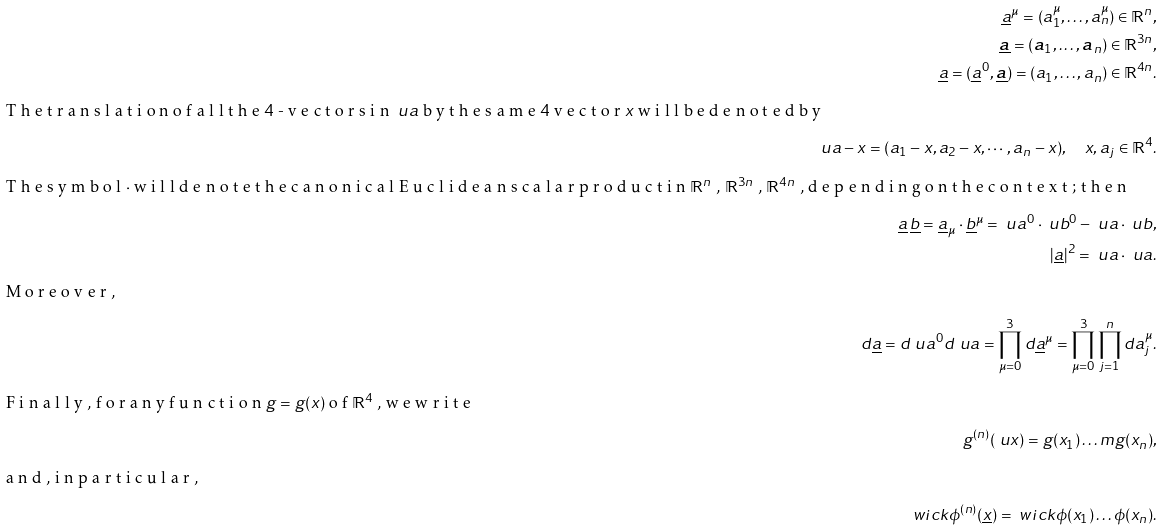Convert formula to latex. <formula><loc_0><loc_0><loc_500><loc_500>\underline { a } ^ { \mu } = ( a _ { 1 } ^ { \mu } , \dots , a _ { n } ^ { \mu } ) \in \mathbb { R } ^ { n } , \\ \underline { \boldsymbol a } = ( { \boldsymbol a } _ { 1 } , \dots , { \boldsymbol a } _ { n } ) \in \mathbb { R } ^ { 3 n } , \\ \underline { a } = ( \underline { a } ^ { 0 } , \underline { \boldsymbol a } ) = ( a _ { 1 } , \dots , a _ { n } ) \in \mathbb { R } ^ { 4 n } . \\ \intertext { T h e t r a n s l a t i o n o f a l l t h e $ 4 $ - v e c t o r s i n $ \ u a $ b y t h e s a m e $ 4 $ v e c t o r $ x $ w i l l b e d e n o t e d b y } \ u a - x = ( a _ { 1 } - x , a _ { 2 } - x , \cdots , a _ { n } - x ) , \quad x , a _ { j } \in \mathbb { R } ^ { 4 } . \\ \intertext { T h e s y m b o l $ \cdot $ w i l l d e n o t e t h e c a n o n i c a l E u c l i d e a n s c a l a r p r o d u c t i n $ \mathbb { R } ^ { n } $ , $ \mathbb { R } ^ { 3 n } $ , $ \mathbb { R } ^ { 4 n } $ , d e p e n d i n g o n t h e c o n t e x t ; t h e n } \underline { a } \, \underline { b } = \underline { a } _ { \mu } \cdot \underline { b } ^ { \mu } = \ u a ^ { 0 } \cdot \ u b ^ { 0 } - \boldsymbol \ u a \cdot \boldsymbol \ u b , \\ | \underline { a } | ^ { 2 } = \ u a \cdot \ u a . \intertext { M o r e o v e r , } d \underline { a } = d \ u a ^ { 0 } d \boldsymbol \ u a = \prod _ { \mu = 0 } ^ { 3 } d \underline { a } ^ { \mu } = \prod _ { \mu = 0 } ^ { 3 } \prod _ { j = 1 } ^ { n } d a ^ { \mu } _ { j } . \\ \intertext { F i n a l l y , f o r a n y f u n c t i o n $ g = g ( x ) $ o f $ \mathbb { R } ^ { 4 } $ , w e w r i t e } g ^ { ( n ) } ( \ u x ) = g ( x _ { 1 } ) \dots m g ( x _ { n } ) , \\ \intertext { a n d , i n p a r t i c u l a r , } \ w i c k { \phi ^ { ( n ) } ( \underline { x } ) } = \ w i c k { \phi ( x _ { 1 } ) \dots \phi ( x _ { n } ) } .</formula> 